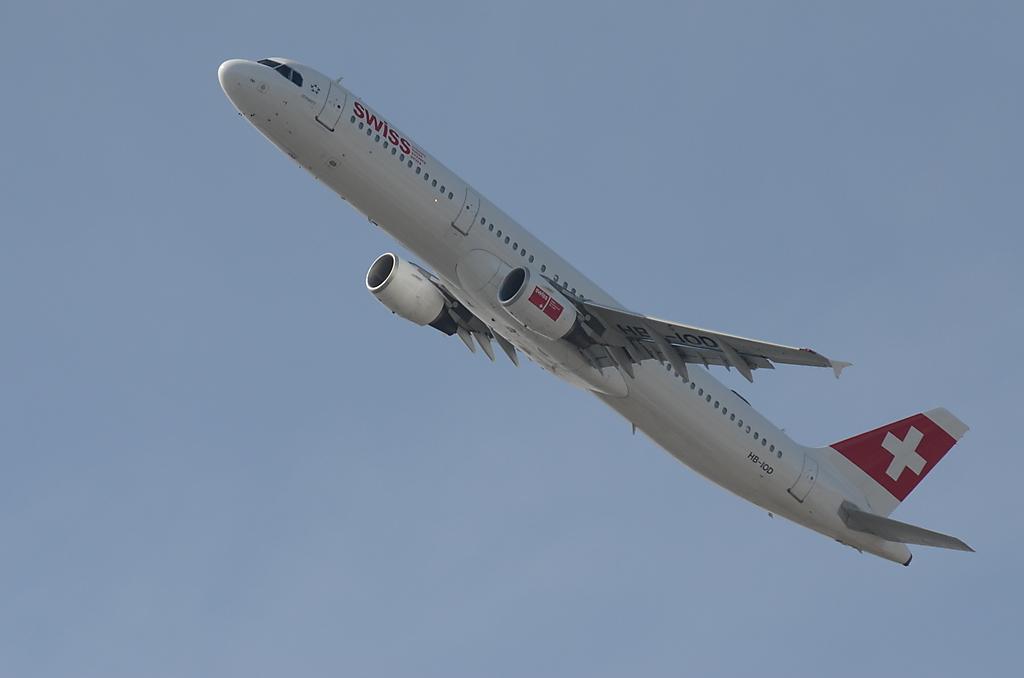Could you give a brief overview of what you see in this image? In this image we can see an airplane flying in the sky. 